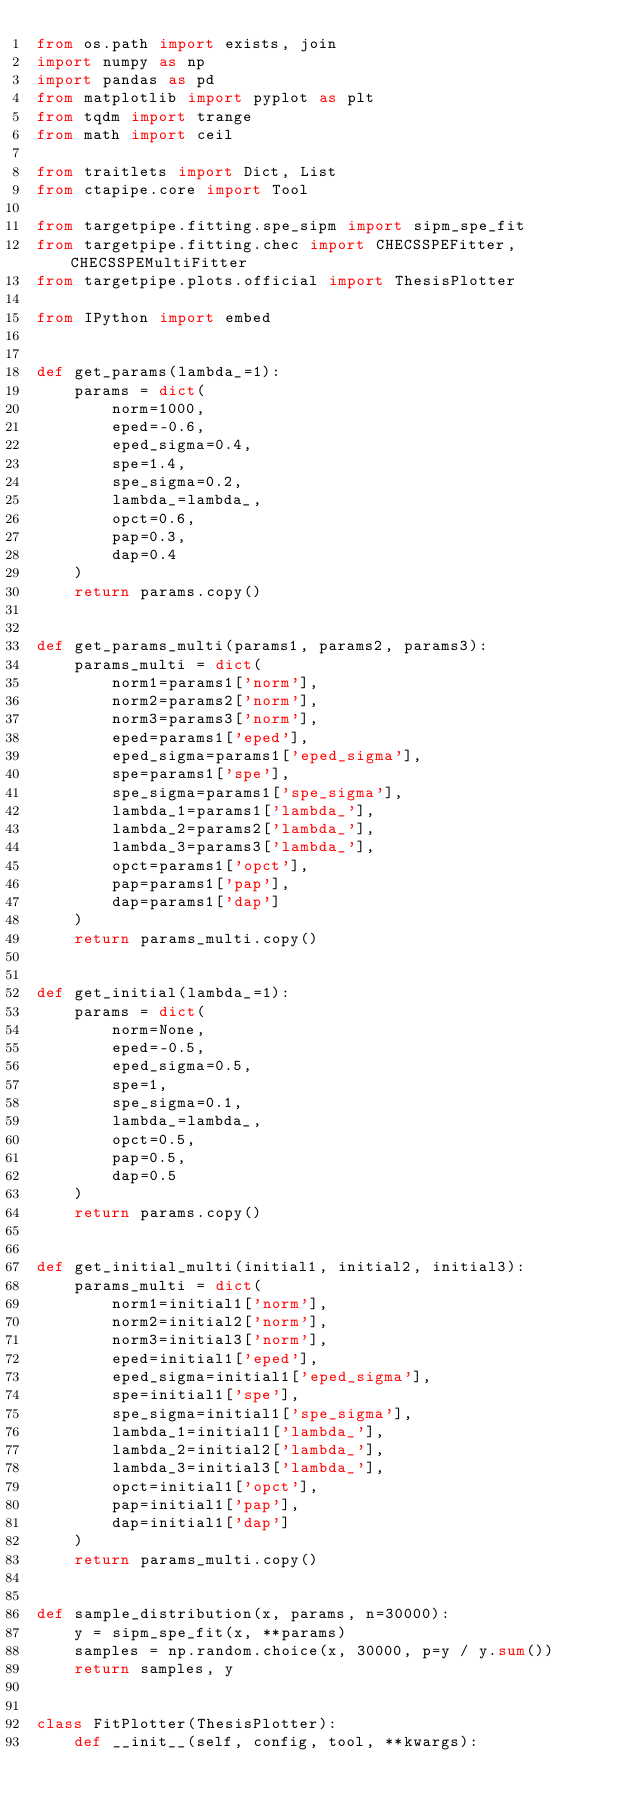<code> <loc_0><loc_0><loc_500><loc_500><_Python_>from os.path import exists, join
import numpy as np
import pandas as pd
from matplotlib import pyplot as plt
from tqdm import trange
from math import ceil

from traitlets import Dict, List
from ctapipe.core import Tool

from targetpipe.fitting.spe_sipm import sipm_spe_fit
from targetpipe.fitting.chec import CHECSSPEFitter, CHECSSPEMultiFitter
from targetpipe.plots.official import ThesisPlotter

from IPython import embed


def get_params(lambda_=1):
    params = dict(
        norm=1000,
        eped=-0.6,
        eped_sigma=0.4,
        spe=1.4,
        spe_sigma=0.2,
        lambda_=lambda_,
        opct=0.6,
        pap=0.3,
        dap=0.4
    )
    return params.copy()


def get_params_multi(params1, params2, params3):
    params_multi = dict(
        norm1=params1['norm'],
        norm2=params2['norm'],
        norm3=params3['norm'],
        eped=params1['eped'],
        eped_sigma=params1['eped_sigma'],
        spe=params1['spe'],
        spe_sigma=params1['spe_sigma'],
        lambda_1=params1['lambda_'],
        lambda_2=params2['lambda_'],
        lambda_3=params3['lambda_'],
        opct=params1['opct'],
        pap=params1['pap'],
        dap=params1['dap']
    )
    return params_multi.copy()


def get_initial(lambda_=1):
    params = dict(
        norm=None,
        eped=-0.5,
        eped_sigma=0.5,
        spe=1,
        spe_sigma=0.1,
        lambda_=lambda_,
        opct=0.5,
        pap=0.5,
        dap=0.5
    )
    return params.copy()


def get_initial_multi(initial1, initial2, initial3):
    params_multi = dict(
        norm1=initial1['norm'],
        norm2=initial2['norm'],
        norm3=initial3['norm'],
        eped=initial1['eped'],
        eped_sigma=initial1['eped_sigma'],
        spe=initial1['spe'],
        spe_sigma=initial1['spe_sigma'],
        lambda_1=initial1['lambda_'],
        lambda_2=initial2['lambda_'],
        lambda_3=initial3['lambda_'],
        opct=initial1['opct'],
        pap=initial1['pap'],
        dap=initial1['dap']
    )
    return params_multi.copy()


def sample_distribution(x, params, n=30000):
    y = sipm_spe_fit(x, **params)
    samples = np.random.choice(x, 30000, p=y / y.sum())
    return samples, y


class FitPlotter(ThesisPlotter):
    def __init__(self, config, tool, **kwargs):</code> 